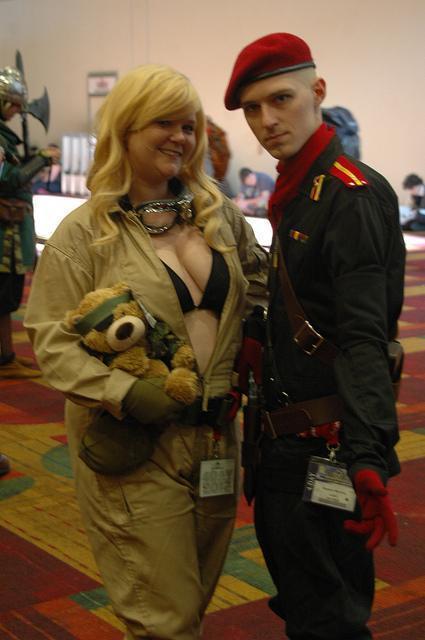What clothes are the people wearing?
Choose the right answer from the provided options to respond to the question.
Options: Uniform, costume, underwear, pajamas. Costume. 